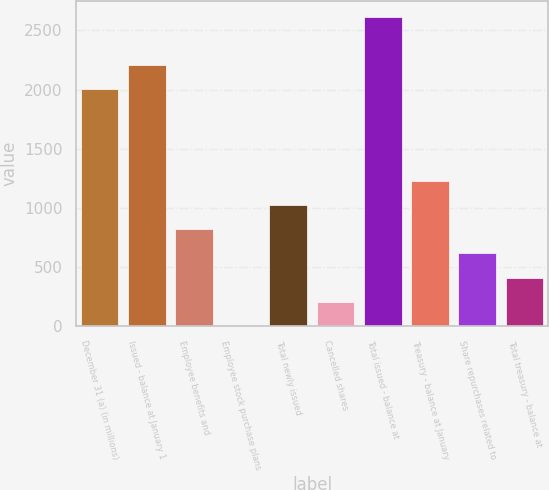Convert chart. <chart><loc_0><loc_0><loc_500><loc_500><bar_chart><fcel>December 31 (a) (in millions)<fcel>Issued - balance at January 1<fcel>Employee benefits and<fcel>Employee stock purchase plans<fcel>Total newly issued<fcel>Cancelled shares<fcel>Total issued - balance at<fcel>Treasury - balance at January<fcel>Share repurchases related to<fcel>Total treasury - balance at<nl><fcel>2003<fcel>2207.37<fcel>818.18<fcel>0.7<fcel>1022.55<fcel>205.07<fcel>2616.11<fcel>1226.92<fcel>613.81<fcel>409.44<nl></chart> 